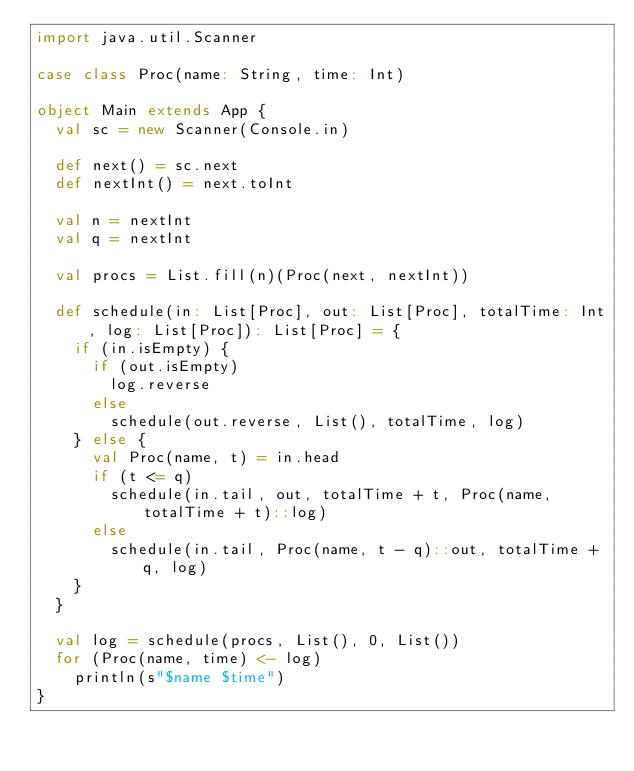Convert code to text. <code><loc_0><loc_0><loc_500><loc_500><_Scala_>import java.util.Scanner

case class Proc(name: String, time: Int)

object Main extends App {
  val sc = new Scanner(Console.in)

  def next() = sc.next
  def nextInt() = next.toInt

  val n = nextInt
  val q = nextInt

  val procs = List.fill(n)(Proc(next, nextInt))

  def schedule(in: List[Proc], out: List[Proc], totalTime: Int, log: List[Proc]): List[Proc] = {
    if (in.isEmpty) {
      if (out.isEmpty)
        log.reverse
      else
        schedule(out.reverse, List(), totalTime, log)
    } else {
      val Proc(name, t) = in.head
      if (t <= q)
        schedule(in.tail, out, totalTime + t, Proc(name, totalTime + t)::log)
      else
        schedule(in.tail, Proc(name, t - q)::out, totalTime + q, log)
    }
  }

  val log = schedule(procs, List(), 0, List())
  for (Proc(name, time) <- log)
    println(s"$name $time")
}

</code> 